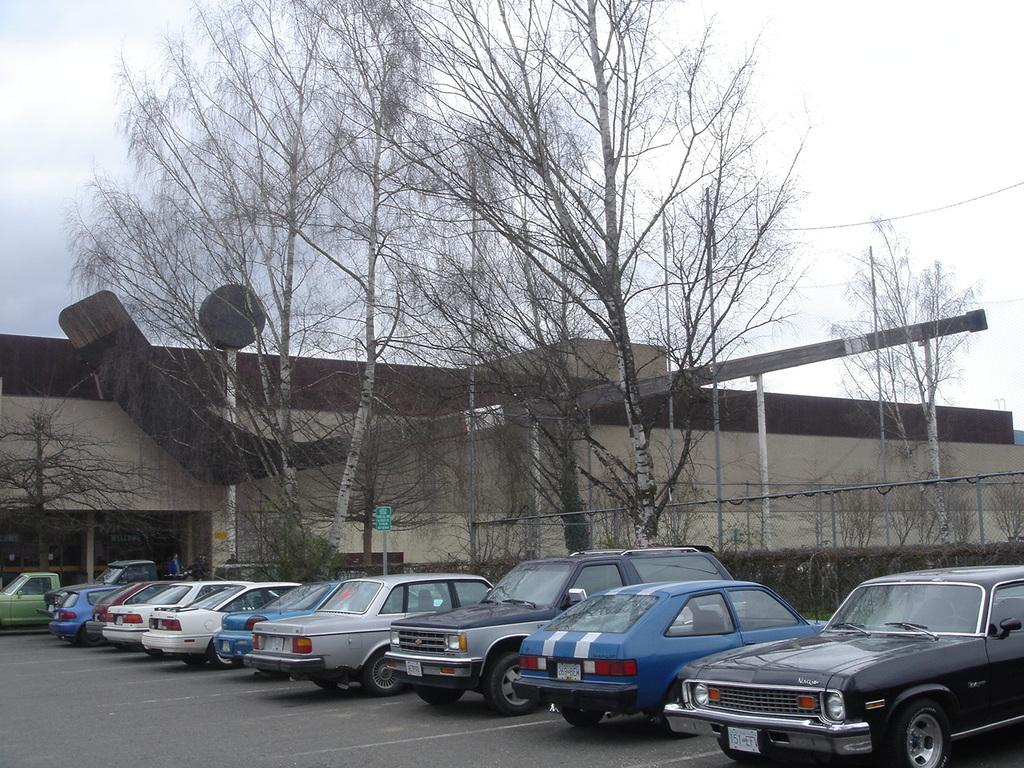What can be seen parked on the road in the image? There are vehicles parked on the road in the image. What type of natural elements are visible in the image? Trees are visible in the image. What are the boards on poles used for? The boards on poles are likely used for signage or advertisements. What type of barrier is present in the image? There is a fence in the image. What type of structure can be seen in the image? There is a building in the image. What is visible in the background of the image? The sky is visible in the background of the image. How many cats are sitting on the roof of the building in the image? There are no cats present in the image; it only features vehicles, trees, boards on poles, a fence, a building, and the sky. 